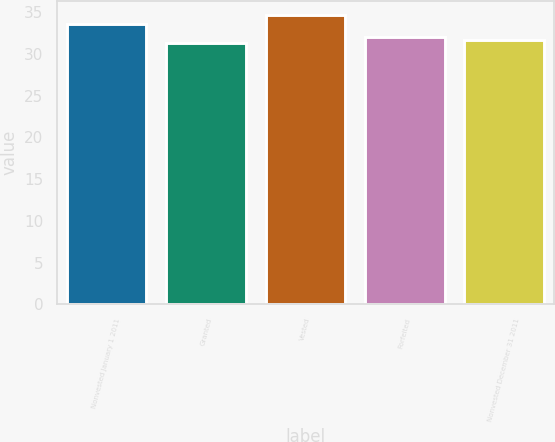Convert chart to OTSL. <chart><loc_0><loc_0><loc_500><loc_500><bar_chart><fcel>Nonvested January 1 2011<fcel>Granted<fcel>Vested<fcel>Forfeited<fcel>Nonvested December 31 2011<nl><fcel>33.58<fcel>31.35<fcel>34.64<fcel>32.01<fcel>31.68<nl></chart> 